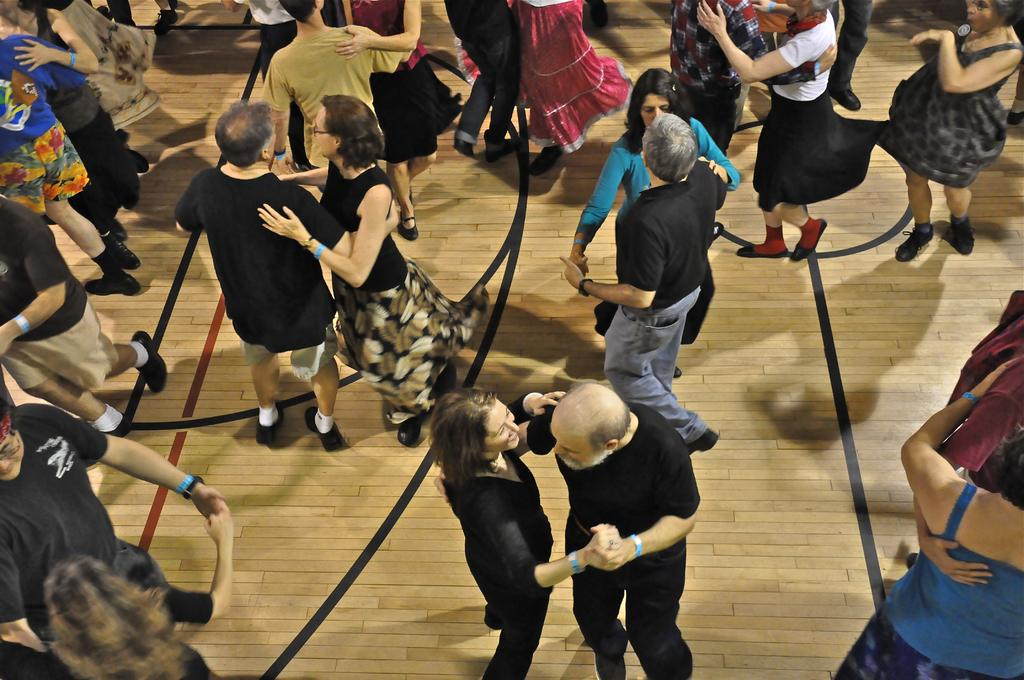What is happening in the image? There are persons in the image, and they are dancing on the floor. Can you describe the actions of the persons in the image? The persons are dancing on the floor. What type of jewel is being used as a prop in the dance? There is no mention of a jewel being used as a prop in the image. How much debt do the persons in the image owe to the dance studio? There is no information about any debt owed by the persons in the image. 